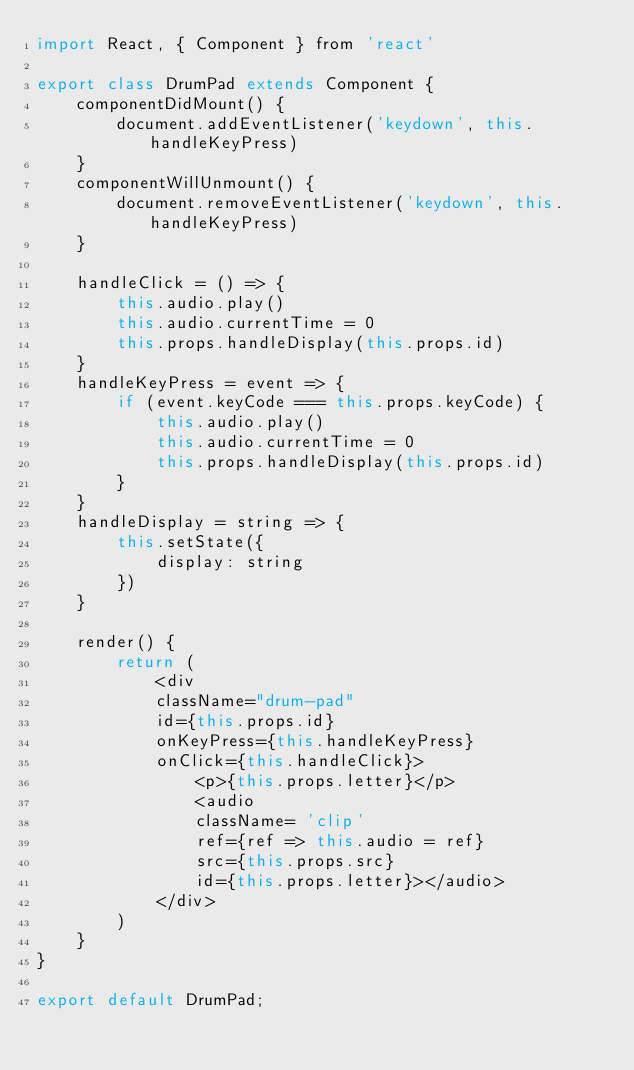<code> <loc_0><loc_0><loc_500><loc_500><_JavaScript_>import React, { Component } from 'react'

export class DrumPad extends Component {
    componentDidMount() {
        document.addEventListener('keydown', this.handleKeyPress)
    }
    componentWillUnmount() {
        document.removeEventListener('keydown', this.handleKeyPress)
    }

    handleClick = () => {
        this.audio.play()
        this.audio.currentTime = 0
        this.props.handleDisplay(this.props.id)
    }
    handleKeyPress = event => {
        if (event.keyCode === this.props.keyCode) {
            this.audio.play()
            this.audio.currentTime = 0
            this.props.handleDisplay(this.props.id)
        }
    }
    handleDisplay = string => {
        this.setState({
            display: string
        })
    }

    render() {
        return (
            <div
            className="drum-pad" 
            id={this.props.id}
            onKeyPress={this.handleKeyPress}
            onClick={this.handleClick}>
                <p>{this.props.letter}</p>
                <audio 
                className= 'clip'
                ref={ref => this.audio = ref}
                src={this.props.src} 
                id={this.props.letter}></audio>
            </div>
        )
    }
}

export default DrumPad;
</code> 